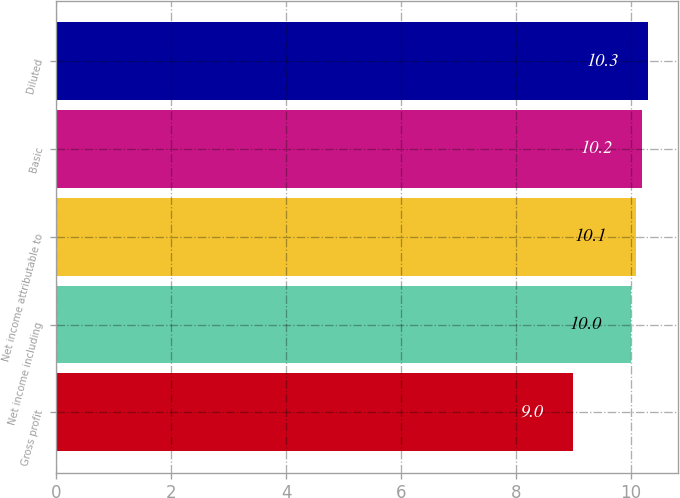Convert chart. <chart><loc_0><loc_0><loc_500><loc_500><bar_chart><fcel>Gross profit<fcel>Net income including<fcel>Net income attributable to<fcel>Basic<fcel>Diluted<nl><fcel>9<fcel>10<fcel>10.1<fcel>10.2<fcel>10.3<nl></chart> 